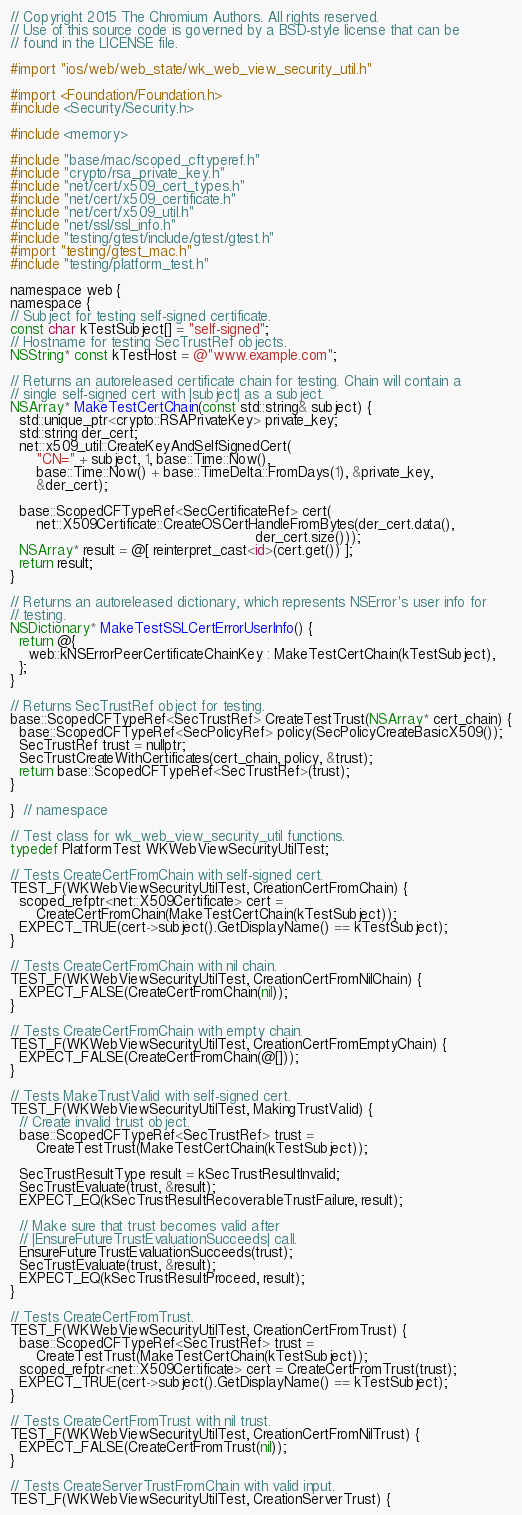<code> <loc_0><loc_0><loc_500><loc_500><_ObjectiveC_>// Copyright 2015 The Chromium Authors. All rights reserved.
// Use of this source code is governed by a BSD-style license that can be
// found in the LICENSE file.

#import "ios/web/web_state/wk_web_view_security_util.h"

#import <Foundation/Foundation.h>
#include <Security/Security.h>

#include <memory>

#include "base/mac/scoped_cftyperef.h"
#include "crypto/rsa_private_key.h"
#include "net/cert/x509_cert_types.h"
#include "net/cert/x509_certificate.h"
#include "net/cert/x509_util.h"
#include "net/ssl/ssl_info.h"
#include "testing/gtest/include/gtest/gtest.h"
#import "testing/gtest_mac.h"
#include "testing/platform_test.h"

namespace web {
namespace {
// Subject for testing self-signed certificate.
const char kTestSubject[] = "self-signed";
// Hostname for testing SecTrustRef objects.
NSString* const kTestHost = @"www.example.com";

// Returns an autoreleased certificate chain for testing. Chain will contain a
// single self-signed cert with |subject| as a subject.
NSArray* MakeTestCertChain(const std::string& subject) {
  std::unique_ptr<crypto::RSAPrivateKey> private_key;
  std::string der_cert;
  net::x509_util::CreateKeyAndSelfSignedCert(
      "CN=" + subject, 1, base::Time::Now(),
      base::Time::Now() + base::TimeDelta::FromDays(1), &private_key,
      &der_cert);

  base::ScopedCFTypeRef<SecCertificateRef> cert(
      net::X509Certificate::CreateOSCertHandleFromBytes(der_cert.data(),
                                                        der_cert.size()));
  NSArray* result = @[ reinterpret_cast<id>(cert.get()) ];
  return result;
}

// Returns an autoreleased dictionary, which represents NSError's user info for
// testing.
NSDictionary* MakeTestSSLCertErrorUserInfo() {
  return @{
    web::kNSErrorPeerCertificateChainKey : MakeTestCertChain(kTestSubject),
  };
}

// Returns SecTrustRef object for testing.
base::ScopedCFTypeRef<SecTrustRef> CreateTestTrust(NSArray* cert_chain) {
  base::ScopedCFTypeRef<SecPolicyRef> policy(SecPolicyCreateBasicX509());
  SecTrustRef trust = nullptr;
  SecTrustCreateWithCertificates(cert_chain, policy, &trust);
  return base::ScopedCFTypeRef<SecTrustRef>(trust);
}

}  // namespace

// Test class for wk_web_view_security_util functions.
typedef PlatformTest WKWebViewSecurityUtilTest;

// Tests CreateCertFromChain with self-signed cert.
TEST_F(WKWebViewSecurityUtilTest, CreationCertFromChain) {
  scoped_refptr<net::X509Certificate> cert =
      CreateCertFromChain(MakeTestCertChain(kTestSubject));
  EXPECT_TRUE(cert->subject().GetDisplayName() == kTestSubject);
}

// Tests CreateCertFromChain with nil chain.
TEST_F(WKWebViewSecurityUtilTest, CreationCertFromNilChain) {
  EXPECT_FALSE(CreateCertFromChain(nil));
}

// Tests CreateCertFromChain with empty chain.
TEST_F(WKWebViewSecurityUtilTest, CreationCertFromEmptyChain) {
  EXPECT_FALSE(CreateCertFromChain(@[]));
}

// Tests MakeTrustValid with self-signed cert.
TEST_F(WKWebViewSecurityUtilTest, MakingTrustValid) {
  // Create invalid trust object.
  base::ScopedCFTypeRef<SecTrustRef> trust =
      CreateTestTrust(MakeTestCertChain(kTestSubject));

  SecTrustResultType result = kSecTrustResultInvalid;
  SecTrustEvaluate(trust, &result);
  EXPECT_EQ(kSecTrustResultRecoverableTrustFailure, result);

  // Make sure that trust becomes valid after
  // |EnsureFutureTrustEvaluationSucceeds| call.
  EnsureFutureTrustEvaluationSucceeds(trust);
  SecTrustEvaluate(trust, &result);
  EXPECT_EQ(kSecTrustResultProceed, result);
}

// Tests CreateCertFromTrust.
TEST_F(WKWebViewSecurityUtilTest, CreationCertFromTrust) {
  base::ScopedCFTypeRef<SecTrustRef> trust =
      CreateTestTrust(MakeTestCertChain(kTestSubject));
  scoped_refptr<net::X509Certificate> cert = CreateCertFromTrust(trust);
  EXPECT_TRUE(cert->subject().GetDisplayName() == kTestSubject);
}

// Tests CreateCertFromTrust with nil trust.
TEST_F(WKWebViewSecurityUtilTest, CreationCertFromNilTrust) {
  EXPECT_FALSE(CreateCertFromTrust(nil));
}

// Tests CreateServerTrustFromChain with valid input.
TEST_F(WKWebViewSecurityUtilTest, CreationServerTrust) {</code> 